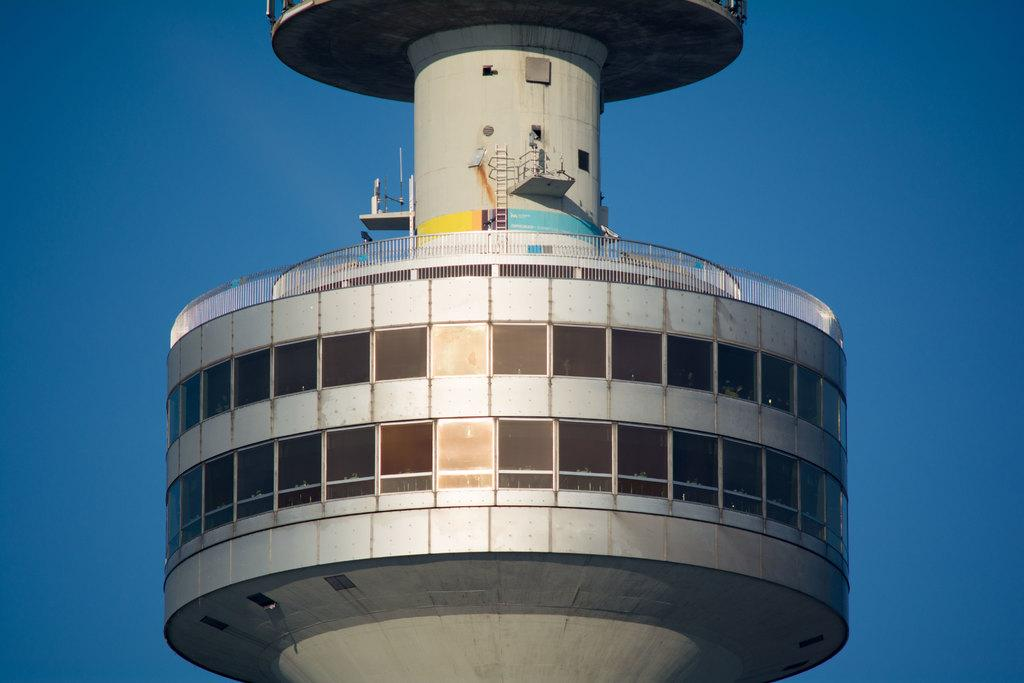What is the main structure in the image? There is a tower in the image. What feature can be seen on the tower? The tower has windows. What is visible in the background of the image? The sky is visible in the image. Where is the library located in the image? A: There is no library present in the image; it only features a tower with windows. What type of system is being used to support the tower in the image? There is no system visible in the image that supports the tower; it appears to be a standalone structure. 